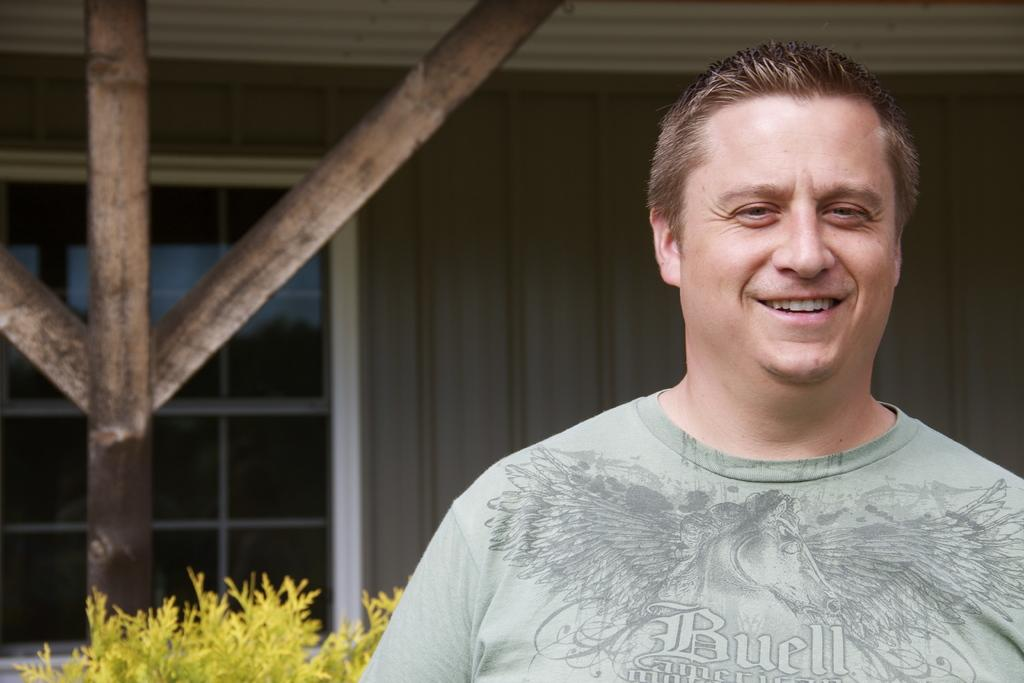Who is present in the image? There is a man in the image. What is the man's facial expression? The man is smiling. What type of vegetation can be seen in the image? There is a plant in the image. What can be seen in the background of the image? There is a wall with a window in the background of the image. What type of toothbrush is the man using in the image? There is no toothbrush present in the image. What material is the silk plant made of in the image? There is no silk plant present in the image. 